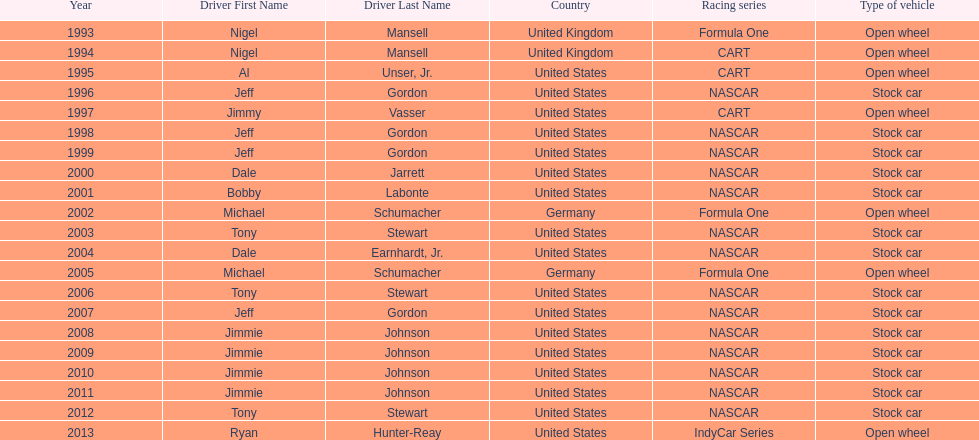Besides nascar, what other racing series have espy-winning drivers come from? Formula One, CART, IndyCar Series. 